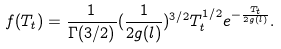<formula> <loc_0><loc_0><loc_500><loc_500>f ( T _ { t } ) = \frac { 1 } { \Gamma ( 3 / 2 ) } ( \frac { 1 } { 2 g ( l ) } ) ^ { 3 / 2 } T _ { t } ^ { 1 / 2 } e ^ { - \frac { T _ { t } } { 2 g ( l ) } } .</formula> 